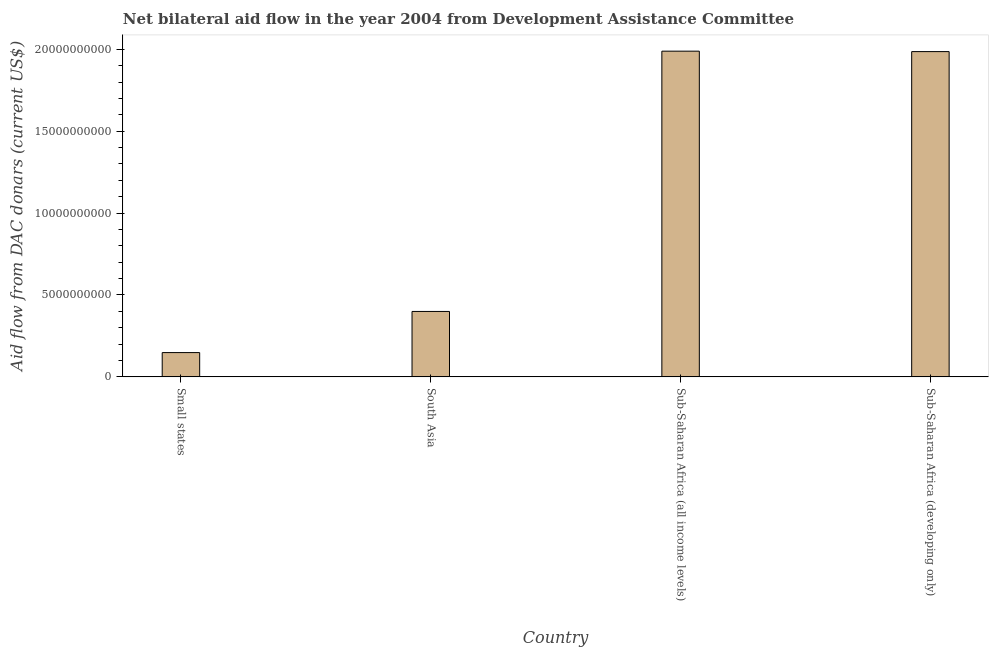What is the title of the graph?
Ensure brevity in your answer.  Net bilateral aid flow in the year 2004 from Development Assistance Committee. What is the label or title of the Y-axis?
Offer a terse response. Aid flow from DAC donars (current US$). What is the net bilateral aid flows from dac donors in Sub-Saharan Africa (all income levels)?
Your answer should be very brief. 1.99e+1. Across all countries, what is the maximum net bilateral aid flows from dac donors?
Provide a short and direct response. 1.99e+1. Across all countries, what is the minimum net bilateral aid flows from dac donors?
Your answer should be compact. 1.48e+09. In which country was the net bilateral aid flows from dac donors maximum?
Your answer should be compact. Sub-Saharan Africa (all income levels). In which country was the net bilateral aid flows from dac donors minimum?
Provide a succinct answer. Small states. What is the sum of the net bilateral aid flows from dac donors?
Provide a short and direct response. 4.52e+1. What is the difference between the net bilateral aid flows from dac donors in South Asia and Sub-Saharan Africa (developing only)?
Your answer should be very brief. -1.59e+1. What is the average net bilateral aid flows from dac donors per country?
Keep it short and to the point. 1.13e+1. What is the median net bilateral aid flows from dac donors?
Your response must be concise. 1.19e+1. In how many countries, is the net bilateral aid flows from dac donors greater than 11000000000 US$?
Offer a terse response. 2. What is the ratio of the net bilateral aid flows from dac donors in Sub-Saharan Africa (all income levels) to that in Sub-Saharan Africa (developing only)?
Your answer should be very brief. 1. Is the net bilateral aid flows from dac donors in Small states less than that in Sub-Saharan Africa (developing only)?
Provide a succinct answer. Yes. What is the difference between the highest and the second highest net bilateral aid flows from dac donors?
Offer a very short reply. 2.68e+07. Is the sum of the net bilateral aid flows from dac donors in Small states and South Asia greater than the maximum net bilateral aid flows from dac donors across all countries?
Your response must be concise. No. What is the difference between the highest and the lowest net bilateral aid flows from dac donors?
Offer a terse response. 1.84e+1. How many bars are there?
Make the answer very short. 4. Are all the bars in the graph horizontal?
Provide a short and direct response. No. Are the values on the major ticks of Y-axis written in scientific E-notation?
Keep it short and to the point. No. What is the Aid flow from DAC donars (current US$) of Small states?
Offer a very short reply. 1.48e+09. What is the Aid flow from DAC donars (current US$) in South Asia?
Offer a very short reply. 4.00e+09. What is the Aid flow from DAC donars (current US$) in Sub-Saharan Africa (all income levels)?
Give a very brief answer. 1.99e+1. What is the Aid flow from DAC donars (current US$) of Sub-Saharan Africa (developing only)?
Your answer should be very brief. 1.99e+1. What is the difference between the Aid flow from DAC donars (current US$) in Small states and South Asia?
Keep it short and to the point. -2.51e+09. What is the difference between the Aid flow from DAC donars (current US$) in Small states and Sub-Saharan Africa (all income levels)?
Your answer should be compact. -1.84e+1. What is the difference between the Aid flow from DAC donars (current US$) in Small states and Sub-Saharan Africa (developing only)?
Your answer should be very brief. -1.84e+1. What is the difference between the Aid flow from DAC donars (current US$) in South Asia and Sub-Saharan Africa (all income levels)?
Ensure brevity in your answer.  -1.59e+1. What is the difference between the Aid flow from DAC donars (current US$) in South Asia and Sub-Saharan Africa (developing only)?
Ensure brevity in your answer.  -1.59e+1. What is the difference between the Aid flow from DAC donars (current US$) in Sub-Saharan Africa (all income levels) and Sub-Saharan Africa (developing only)?
Keep it short and to the point. 2.68e+07. What is the ratio of the Aid flow from DAC donars (current US$) in Small states to that in South Asia?
Your answer should be very brief. 0.37. What is the ratio of the Aid flow from DAC donars (current US$) in Small states to that in Sub-Saharan Africa (all income levels)?
Give a very brief answer. 0.07. What is the ratio of the Aid flow from DAC donars (current US$) in Small states to that in Sub-Saharan Africa (developing only)?
Keep it short and to the point. 0.07. What is the ratio of the Aid flow from DAC donars (current US$) in South Asia to that in Sub-Saharan Africa (all income levels)?
Offer a very short reply. 0.2. What is the ratio of the Aid flow from DAC donars (current US$) in South Asia to that in Sub-Saharan Africa (developing only)?
Ensure brevity in your answer.  0.2. What is the ratio of the Aid flow from DAC donars (current US$) in Sub-Saharan Africa (all income levels) to that in Sub-Saharan Africa (developing only)?
Your answer should be very brief. 1. 